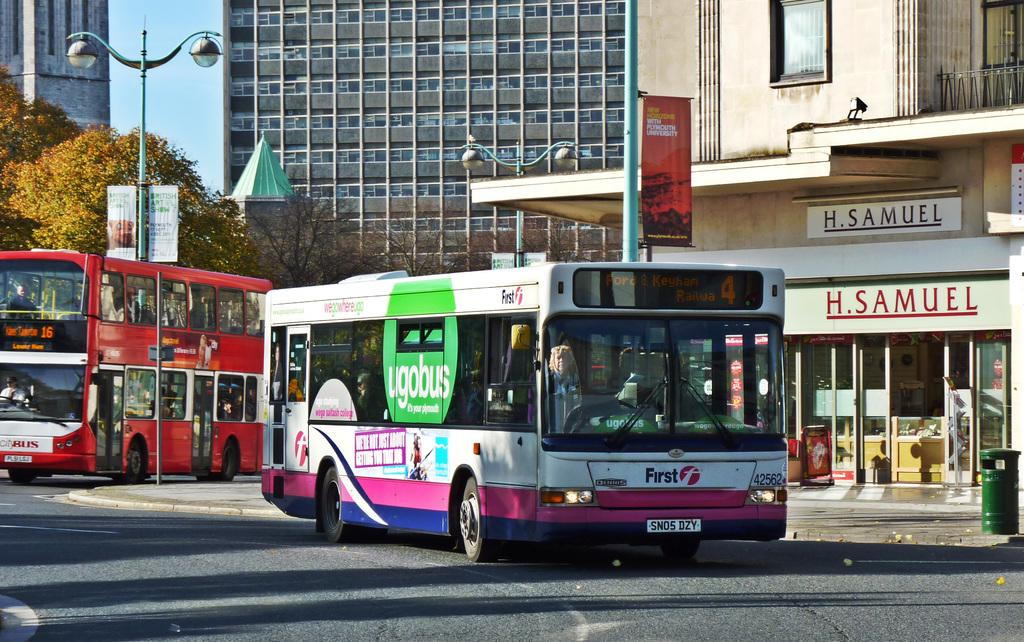What type of vehicles are on the road in the image? There are two buses on the road in the image. What is located behind the buses? There is a street lamp behind the buses. What type of vegetation can be seen in the image? There are trees visible in the image. What can be seen in the background of the image? There are buildings in the background of the image. What language is being spoken by the buses in the image? Buses do not speak languages; they are inanimate objects. The image does not provide any information about spoken languages. 